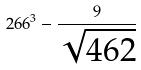<formula> <loc_0><loc_0><loc_500><loc_500>2 6 6 ^ { 3 } - \frac { 9 } { \sqrt { 4 6 2 } }</formula> 